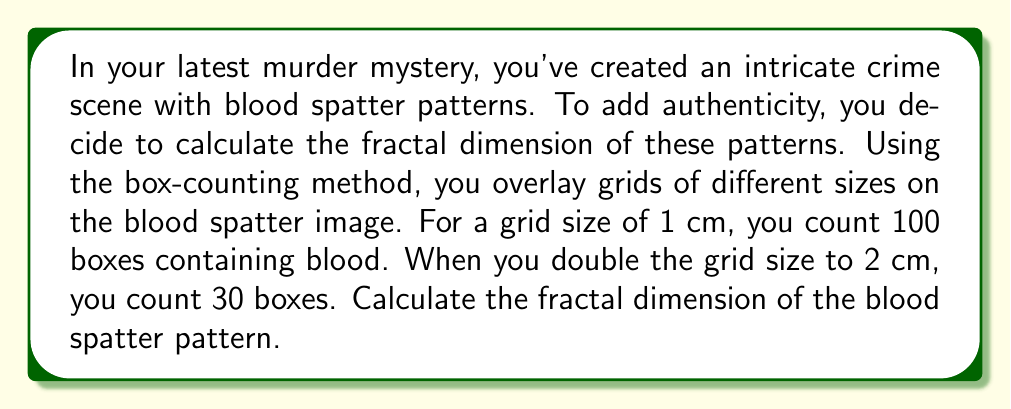Show me your answer to this math problem. To calculate the fractal dimension using the box-counting method, we'll follow these steps:

1. The fractal dimension $D$ is given by the formula:

   $$D = -\frac{\log(N_2/N_1)}{\log(r_2/r_1)}$$

   Where:
   - $N_1$ and $N_2$ are the number of boxes counted at different scales
   - $r_1$ and $r_2$ are the corresponding grid sizes

2. In this case:
   - $N_1 = 100$ (boxes for 1 cm grid)
   - $N_2 = 30$ (boxes for 2 cm grid)
   - $r_1 = 1$ cm
   - $r_2 = 2$ cm

3. Let's substitute these values into the formula:

   $$D = -\frac{\log(30/100)}{\log(2/1)}$$

4. Simplify:
   $$D = -\frac{\log(0.3)}{\log(2)}$$

5. Calculate:
   $$D \approx 1.7370$$

The fractal dimension lies between 1 (a line) and 2 (a filled plane), indicating a complex, fractal-like pattern typical of blood spatter.
Answer: $1.7370$ 